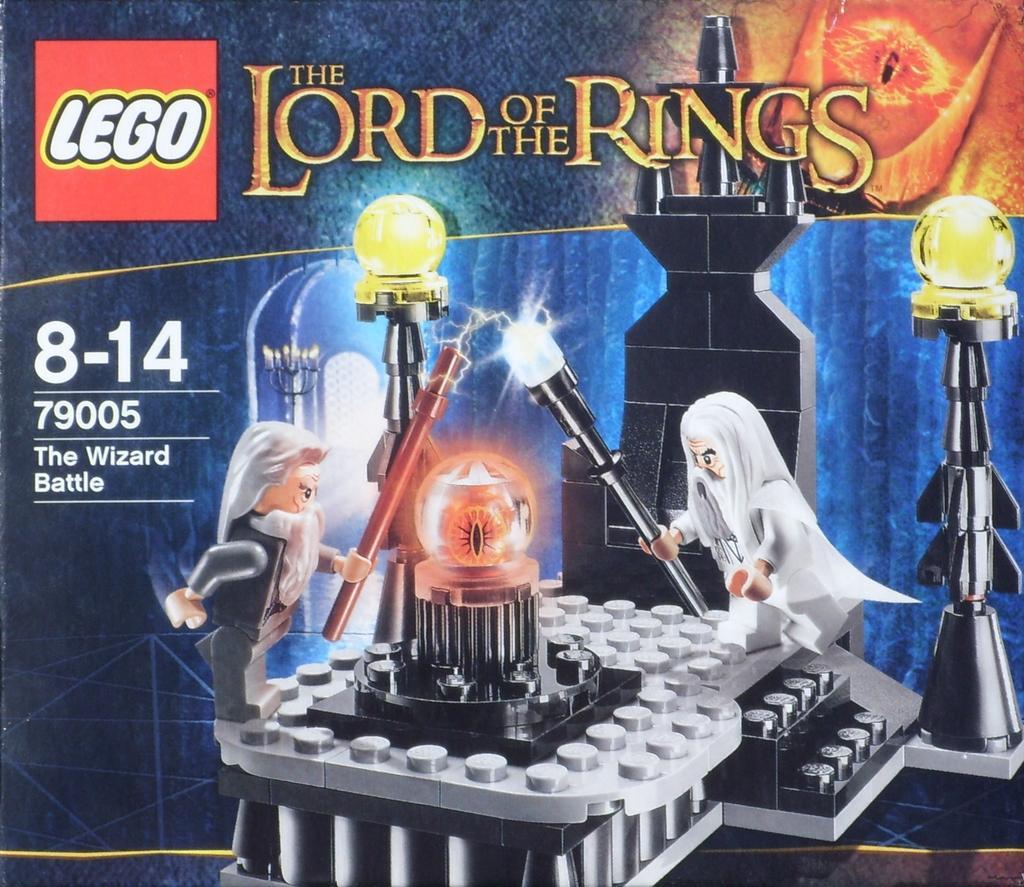Describe this image in one or two sentences. This is an animated picture. In the center there is a white color object. On the right there is a person holding a stick and standing on the ground. On the left there is another person holding a stick and standing on the ground. In the background we can see some other objects and we can see the text on the image. 